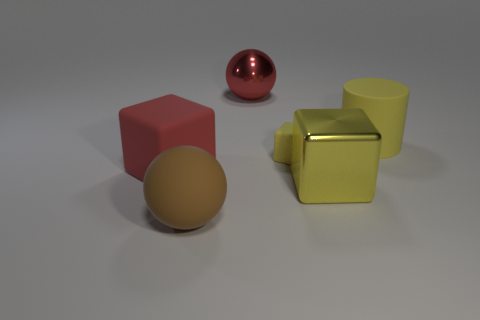Add 3 tiny yellow matte things. How many objects exist? 9 Subtract all cylinders. How many objects are left? 5 Subtract all large cyan matte things. Subtract all yellow rubber cylinders. How many objects are left? 5 Add 6 shiny cubes. How many shiny cubes are left? 7 Add 2 big yellow metal objects. How many big yellow metal objects exist? 3 Subtract 0 blue cylinders. How many objects are left? 6 